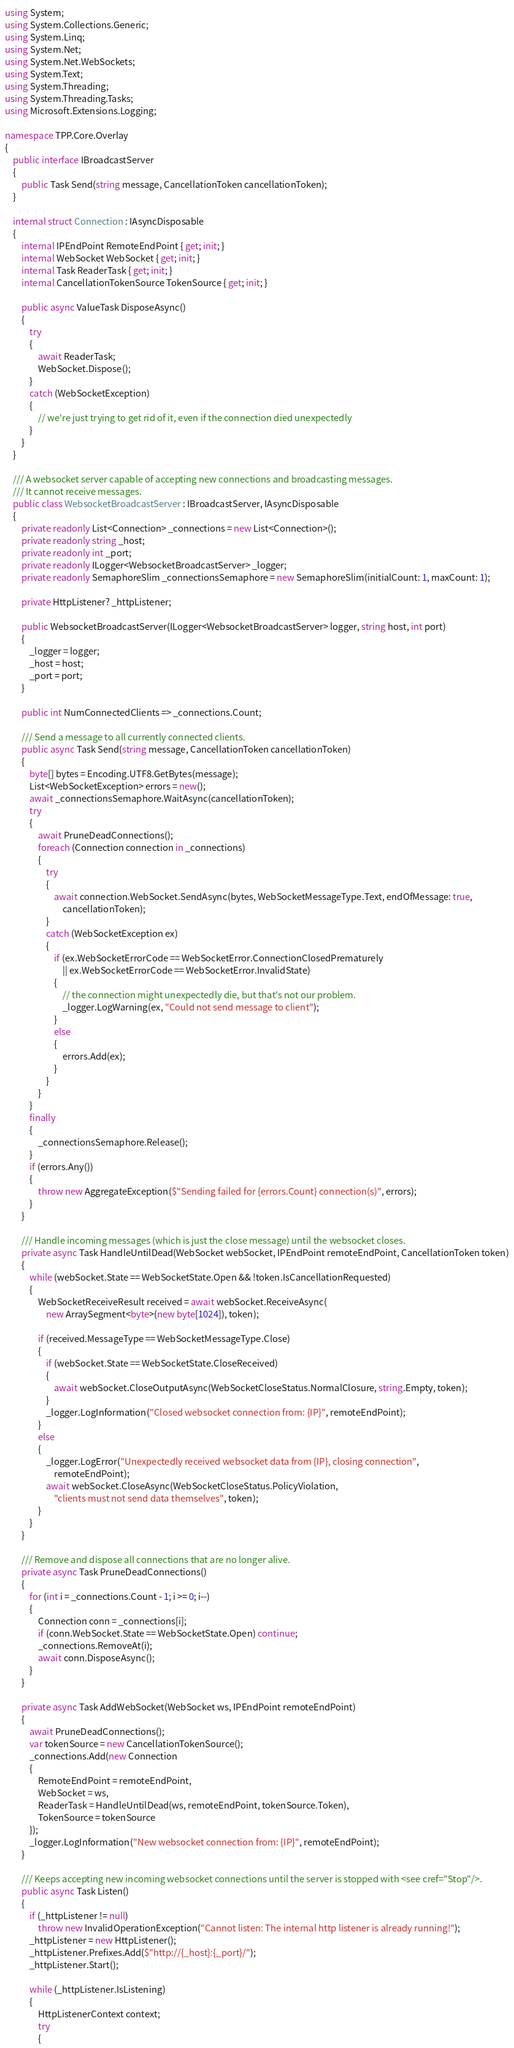<code> <loc_0><loc_0><loc_500><loc_500><_C#_>using System;
using System.Collections.Generic;
using System.Linq;
using System.Net;
using System.Net.WebSockets;
using System.Text;
using System.Threading;
using System.Threading.Tasks;
using Microsoft.Extensions.Logging;

namespace TPP.Core.Overlay
{
    public interface IBroadcastServer
    {
        public Task Send(string message, CancellationToken cancellationToken);
    }

    internal struct Connection : IAsyncDisposable
    {
        internal IPEndPoint RemoteEndPoint { get; init; }
        internal WebSocket WebSocket { get; init; }
        internal Task ReaderTask { get; init; }
        internal CancellationTokenSource TokenSource { get; init; }

        public async ValueTask DisposeAsync()
        {
            try
            {
                await ReaderTask;
                WebSocket.Dispose();
            }
            catch (WebSocketException)
            {
                // we're just trying to get rid of it, even if the connection died unexpectedly
            }
        }
    }

    /// A websocket server capable of accepting new connections and broadcasting messages.
    /// It cannot receive messages.
    public class WebsocketBroadcastServer : IBroadcastServer, IAsyncDisposable
    {
        private readonly List<Connection> _connections = new List<Connection>();
        private readonly string _host;
        private readonly int _port;
        private readonly ILogger<WebsocketBroadcastServer> _logger;
        private readonly SemaphoreSlim _connectionsSemaphore = new SemaphoreSlim(initialCount: 1, maxCount: 1);

        private HttpListener? _httpListener;

        public WebsocketBroadcastServer(ILogger<WebsocketBroadcastServer> logger, string host, int port)
        {
            _logger = logger;
            _host = host;
            _port = port;
        }

        public int NumConnectedClients => _connections.Count;

        /// Send a message to all currently connected clients.
        public async Task Send(string message, CancellationToken cancellationToken)
        {
            byte[] bytes = Encoding.UTF8.GetBytes(message);
            List<WebSocketException> errors = new();
            await _connectionsSemaphore.WaitAsync(cancellationToken);
            try
            {
                await PruneDeadConnections();
                foreach (Connection connection in _connections)
                {
                    try
                    {
                        await connection.WebSocket.SendAsync(bytes, WebSocketMessageType.Text, endOfMessage: true,
                            cancellationToken);
                    }
                    catch (WebSocketException ex)
                    {
                        if (ex.WebSocketErrorCode == WebSocketError.ConnectionClosedPrematurely
                            || ex.WebSocketErrorCode == WebSocketError.InvalidState)
                        {
                            // the connection might unexpectedly die, but that's not our problem.
                            _logger.LogWarning(ex, "Could not send message to client");
                        }
                        else
                        {
                            errors.Add(ex);
                        }
                    }
                }
            }
            finally
            {
                _connectionsSemaphore.Release();
            }
            if (errors.Any())
            {
                throw new AggregateException($"Sending failed for {errors.Count} connection(s)", errors);
            }
        }

        /// Handle incoming messages (which is just the close message) until the websocket closes.
        private async Task HandleUntilDead(WebSocket webSocket, IPEndPoint remoteEndPoint, CancellationToken token)
        {
            while (webSocket.State == WebSocketState.Open && !token.IsCancellationRequested)
            {
                WebSocketReceiveResult received = await webSocket.ReceiveAsync(
                    new ArraySegment<byte>(new byte[1024]), token);

                if (received.MessageType == WebSocketMessageType.Close)
                {
                    if (webSocket.State == WebSocketState.CloseReceived)
                    {
                        await webSocket.CloseOutputAsync(WebSocketCloseStatus.NormalClosure, string.Empty, token);
                    }
                    _logger.LogInformation("Closed websocket connection from: {IP}", remoteEndPoint);
                }
                else
                {
                    _logger.LogError("Unexpectedly received websocket data from {IP}, closing connection",
                        remoteEndPoint);
                    await webSocket.CloseAsync(WebSocketCloseStatus.PolicyViolation,
                        "clients must not send data themselves", token);
                }
            }
        }

        /// Remove and dispose all connections that are no longer alive.
        private async Task PruneDeadConnections()
        {
            for (int i = _connections.Count - 1; i >= 0; i--)
            {
                Connection conn = _connections[i];
                if (conn.WebSocket.State == WebSocketState.Open) continue;
                _connections.RemoveAt(i);
                await conn.DisposeAsync();
            }
        }

        private async Task AddWebSocket(WebSocket ws, IPEndPoint remoteEndPoint)
        {
            await PruneDeadConnections();
            var tokenSource = new CancellationTokenSource();
            _connections.Add(new Connection
            {
                RemoteEndPoint = remoteEndPoint,
                WebSocket = ws,
                ReaderTask = HandleUntilDead(ws, remoteEndPoint, tokenSource.Token),
                TokenSource = tokenSource
            });
            _logger.LogInformation("New websocket connection from: {IP}", remoteEndPoint);
        }

        /// Keeps accepting new incoming websocket connections until the server is stopped with <see cref="Stop"/>.
        public async Task Listen()
        {
            if (_httpListener != null)
                throw new InvalidOperationException("Cannot listen: The internal http listener is already running!");
            _httpListener = new HttpListener();
            _httpListener.Prefixes.Add($"http://{_host}:{_port}/");
            _httpListener.Start();

            while (_httpListener.IsListening)
            {
                HttpListenerContext context;
                try
                {</code> 